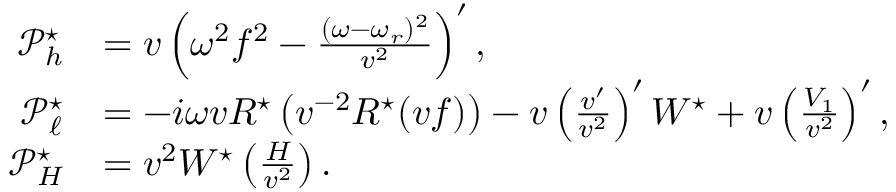Convert formula to latex. <formula><loc_0><loc_0><loc_500><loc_500>\begin{array} { r l } { \mathcal { P } _ { h } ^ { ^ { * } } } & { = v \left ( \omega ^ { 2 } f ^ { 2 } - \frac { ( \omega - \omega _ { r } ) ^ { 2 } } { v ^ { 2 } } \right ) ^ { \prime } , } \\ { \mathcal { P } _ { \ell } ^ { ^ { * } } } & { = - i \omega v R ^ { ^ { * } } \left ( v ^ { - 2 } R ^ { ^ { * } } ( v f ) \right ) - v \left ( \frac { v ^ { \prime } } { v ^ { 2 } } \right ) ^ { \prime } W ^ { ^ { * } } + v \left ( \frac { V _ { 1 } } { v ^ { 2 } } \right ) ^ { \prime } , } \\ { \mathcal { P } _ { H } ^ { ^ { * } } } & { = v ^ { 2 } W ^ { ^ { * } } \left ( \frac { H } { v ^ { 2 } } \right ) . } \end{array}</formula> 